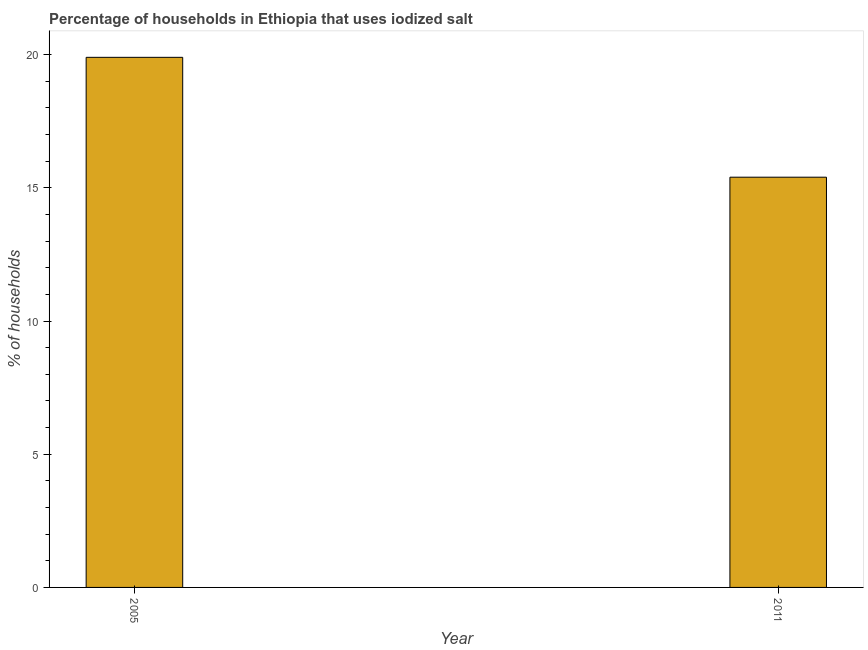Does the graph contain grids?
Your response must be concise. No. What is the title of the graph?
Your response must be concise. Percentage of households in Ethiopia that uses iodized salt. What is the label or title of the X-axis?
Make the answer very short. Year. What is the label or title of the Y-axis?
Your answer should be very brief. % of households. What is the percentage of households where iodized salt is consumed in 2005?
Offer a terse response. 19.9. Across all years, what is the maximum percentage of households where iodized salt is consumed?
Ensure brevity in your answer.  19.9. In which year was the percentage of households where iodized salt is consumed minimum?
Ensure brevity in your answer.  2011. What is the sum of the percentage of households where iodized salt is consumed?
Offer a terse response. 35.3. What is the average percentage of households where iodized salt is consumed per year?
Make the answer very short. 17.65. What is the median percentage of households where iodized salt is consumed?
Your response must be concise. 17.65. In how many years, is the percentage of households where iodized salt is consumed greater than 13 %?
Your response must be concise. 2. What is the ratio of the percentage of households where iodized salt is consumed in 2005 to that in 2011?
Keep it short and to the point. 1.29. What is the difference between two consecutive major ticks on the Y-axis?
Your answer should be compact. 5. What is the % of households in 2005?
Make the answer very short. 19.9. What is the ratio of the % of households in 2005 to that in 2011?
Provide a succinct answer. 1.29. 